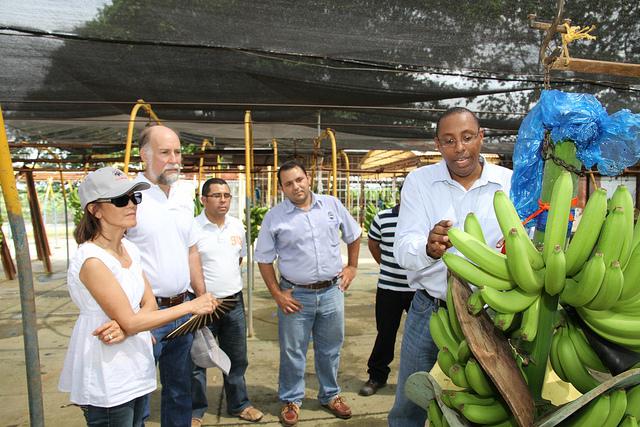How many people have glasses?
Write a very short answer. 3. Are the bananas yellow?
Concise answer only. No. What are the people looking at?
Concise answer only. Bananas. 